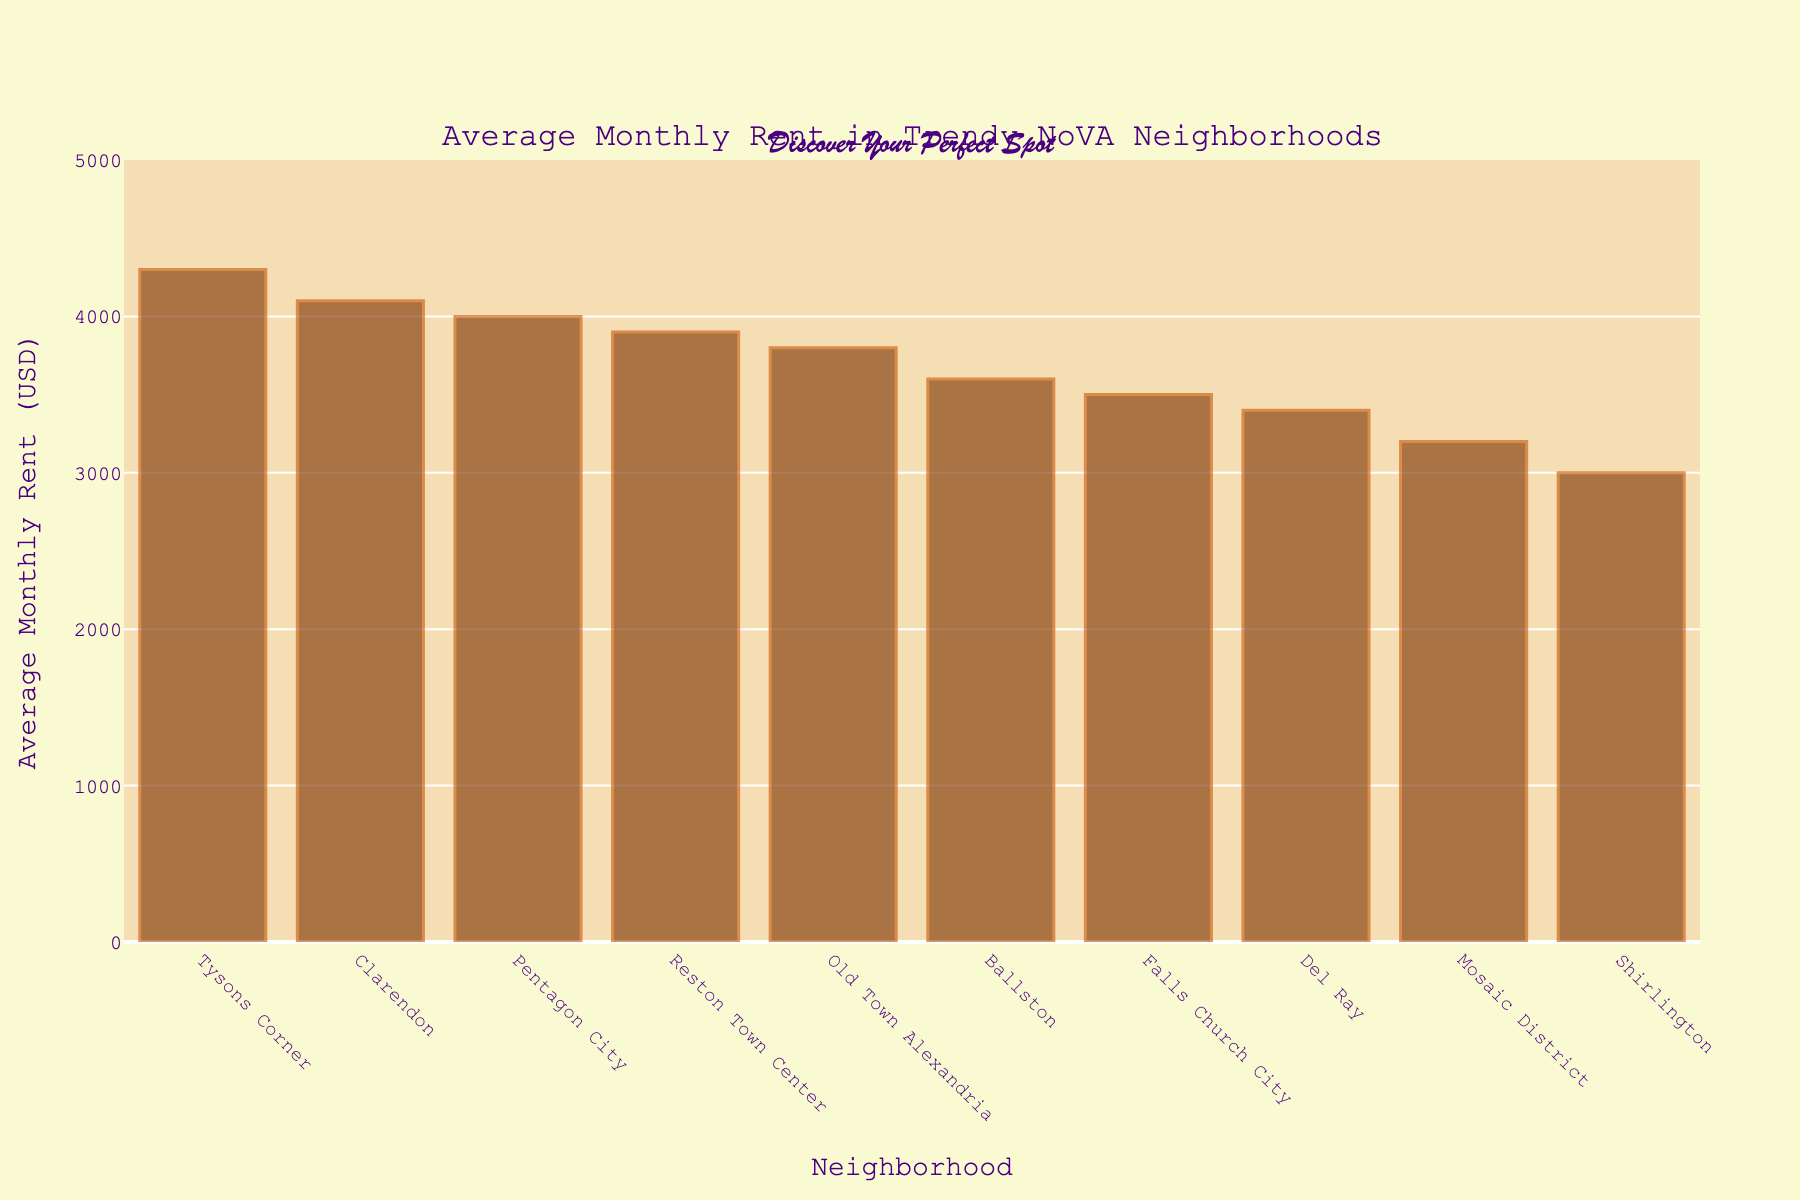Which neighborhood has the highest average monthly rent? The tallest bar represents the highest rent. Tysons Corner has the tallest bar in the chart, indicating the highest average monthly rent.
Answer: Tysons Corner Which neighborhood has the lowest average monthly rent? The shortest bar represents the lowest rent. Shirlington has the shortest bar in the chart, indicating the lowest average monthly rent.
Answer: Shirlington How much higher is the average rent in Tysons Corner compared to Shirlington? Find the heights of the bars for Tysons Corner and Shirlington. The difference between Tysons Corner ($4300) and Shirlington ($3000) is calculated by $4300 - $3000.
Answer: $1300 What is the average rent for Old Town Alexandria and Reston Town Center combined? Add the rent values for Old Town Alexandria ($3800) and Reston Town Center ($3900), and then divide by 2 for the average. Thus, ($3800 + $3900)/2.
Answer: $3850 Which neighborhoods have higher average rents than Pentagon City? Identify the neighborhoods with bars taller than Pentagon City ($4000). Both Tysons Corner ($4300) and Clarendon ($4100) have higher rents.
Answer: Tysons Corner, Clarendon Is the rent in Falls Church City closer to Del Ray's or Ballston's rent? Compare Falls Church City’s rent ($3500) to Del Ray ($3400) and Ballston ($3600). The differences are $100 to Del Ray and $100 to Ballston. Since both differences are equal, it's closer to both.
Answer: Both What's the total average rent for the 3 most expensive neighborhoods? Identify the highest rents: Tysons Corner ($4300), Clarendon ($4100), and Pentagon City ($4000). Add these values $4300 + $4100 + $4000.
Answer: $12400 How does the average rent in Mosaic District compare to Falls Church City? Compare Mosaic District’s rent ($3200) to Falls Church City ($3500). Mosaic District’s rent is lower.
Answer: Lower What is the difference between the highest and lowest average rents among the neighborhoods? Identify the highest rent (Tysons Corner, $4300) and the lowest rent (Shirlington, $3000). Calculate: $4300 - $3000.
Answer: $1300 What is the median average rent of the neighborhoods? List the rents in ascending order and find the middle value. Sorted rents: $3000, $3200, $3400, $3500, $3600, $3800, $3900, $4000, $4100, $4300. The middle values are $3600 (Ballston) and $3800 (Old Town Alexandria). Median is ($3600 + $3800)/2.
Answer: $3700 